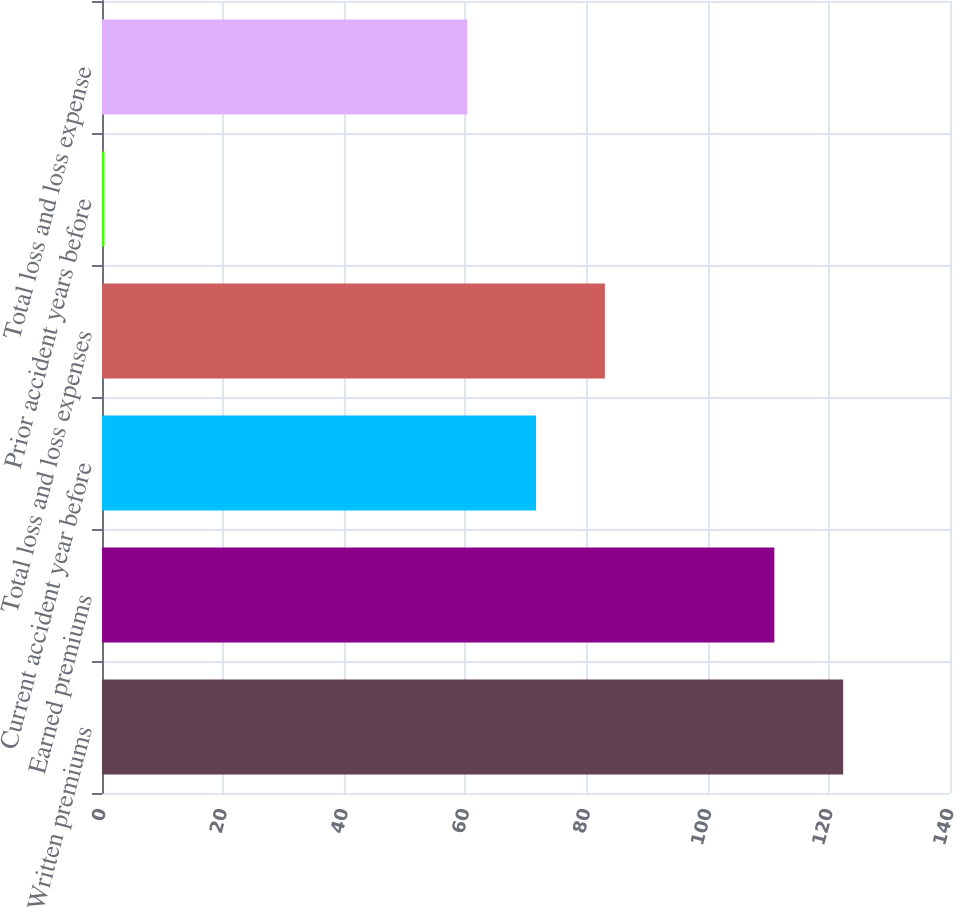Convert chart to OTSL. <chart><loc_0><loc_0><loc_500><loc_500><bar_chart><fcel>Written premiums<fcel>Earned premiums<fcel>Current accident year before<fcel>Total loss and loss expenses<fcel>Prior accident years before<fcel>Total loss and loss expense<nl><fcel>122.36<fcel>111<fcel>71.66<fcel>83.02<fcel>0.4<fcel>60.3<nl></chart> 